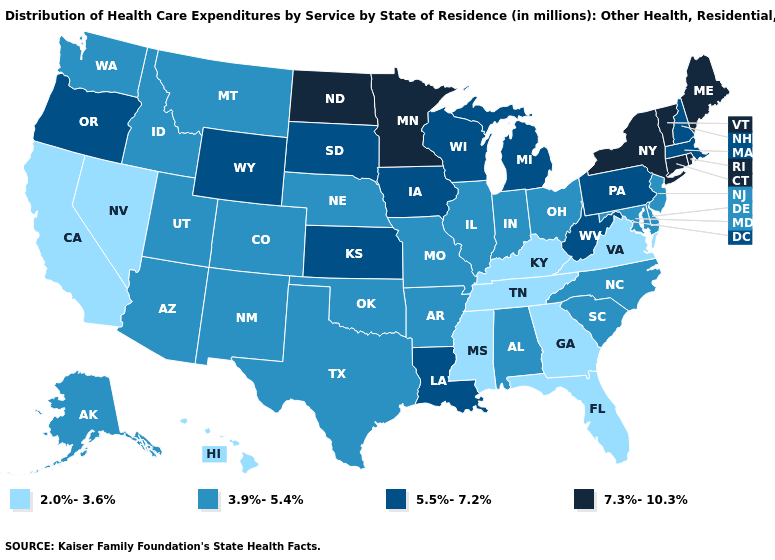Which states have the lowest value in the USA?
Short answer required. California, Florida, Georgia, Hawaii, Kentucky, Mississippi, Nevada, Tennessee, Virginia. Name the states that have a value in the range 7.3%-10.3%?
Short answer required. Connecticut, Maine, Minnesota, New York, North Dakota, Rhode Island, Vermont. Is the legend a continuous bar?
Answer briefly. No. Name the states that have a value in the range 2.0%-3.6%?
Concise answer only. California, Florida, Georgia, Hawaii, Kentucky, Mississippi, Nevada, Tennessee, Virginia. Does Nevada have the highest value in the West?
Give a very brief answer. No. Name the states that have a value in the range 3.9%-5.4%?
Give a very brief answer. Alabama, Alaska, Arizona, Arkansas, Colorado, Delaware, Idaho, Illinois, Indiana, Maryland, Missouri, Montana, Nebraska, New Jersey, New Mexico, North Carolina, Ohio, Oklahoma, South Carolina, Texas, Utah, Washington. Name the states that have a value in the range 7.3%-10.3%?
Keep it brief. Connecticut, Maine, Minnesota, New York, North Dakota, Rhode Island, Vermont. What is the lowest value in states that border Idaho?
Concise answer only. 2.0%-3.6%. What is the value of North Dakota?
Quick response, please. 7.3%-10.3%. Name the states that have a value in the range 3.9%-5.4%?
Short answer required. Alabama, Alaska, Arizona, Arkansas, Colorado, Delaware, Idaho, Illinois, Indiana, Maryland, Missouri, Montana, Nebraska, New Jersey, New Mexico, North Carolina, Ohio, Oklahoma, South Carolina, Texas, Utah, Washington. Which states hav the highest value in the MidWest?
Quick response, please. Minnesota, North Dakota. Does North Carolina have the same value as Missouri?
Be succinct. Yes. Name the states that have a value in the range 2.0%-3.6%?
Give a very brief answer. California, Florida, Georgia, Hawaii, Kentucky, Mississippi, Nevada, Tennessee, Virginia. Name the states that have a value in the range 5.5%-7.2%?
Be succinct. Iowa, Kansas, Louisiana, Massachusetts, Michigan, New Hampshire, Oregon, Pennsylvania, South Dakota, West Virginia, Wisconsin, Wyoming. Does Minnesota have the lowest value in the USA?
Concise answer only. No. 